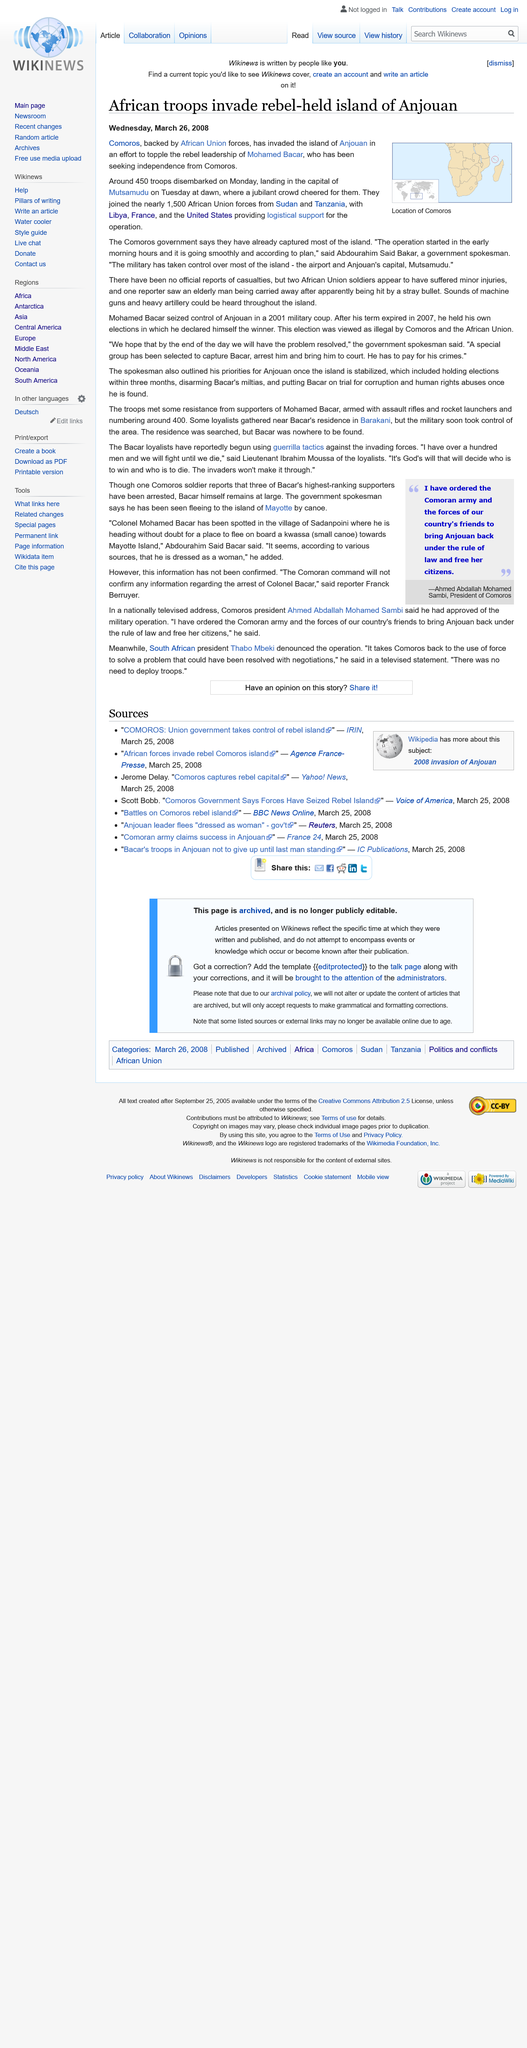Give some essential details in this illustration. The United States, France, and Libya provided logistical support for the operation. Around 450 troops landed on the island of Anjouan and in the capital city of the island. On March 27, 2008, the government of Comoros invaded the island of Anjouan with the objective of toppling the rebel leader, Mohamed Bacar, who had taken control of the island in 2006. 